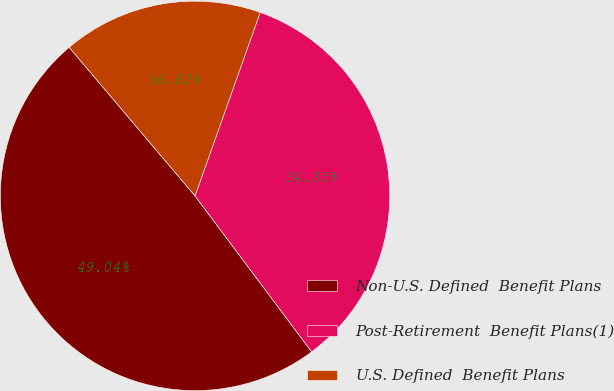Convert chart to OTSL. <chart><loc_0><loc_0><loc_500><loc_500><pie_chart><fcel>Non-U.S. Defined  Benefit Plans<fcel>Post-Retirement  Benefit Plans(1)<fcel>U.S. Defined  Benefit Plans<nl><fcel>49.04%<fcel>34.35%<fcel>16.62%<nl></chart> 